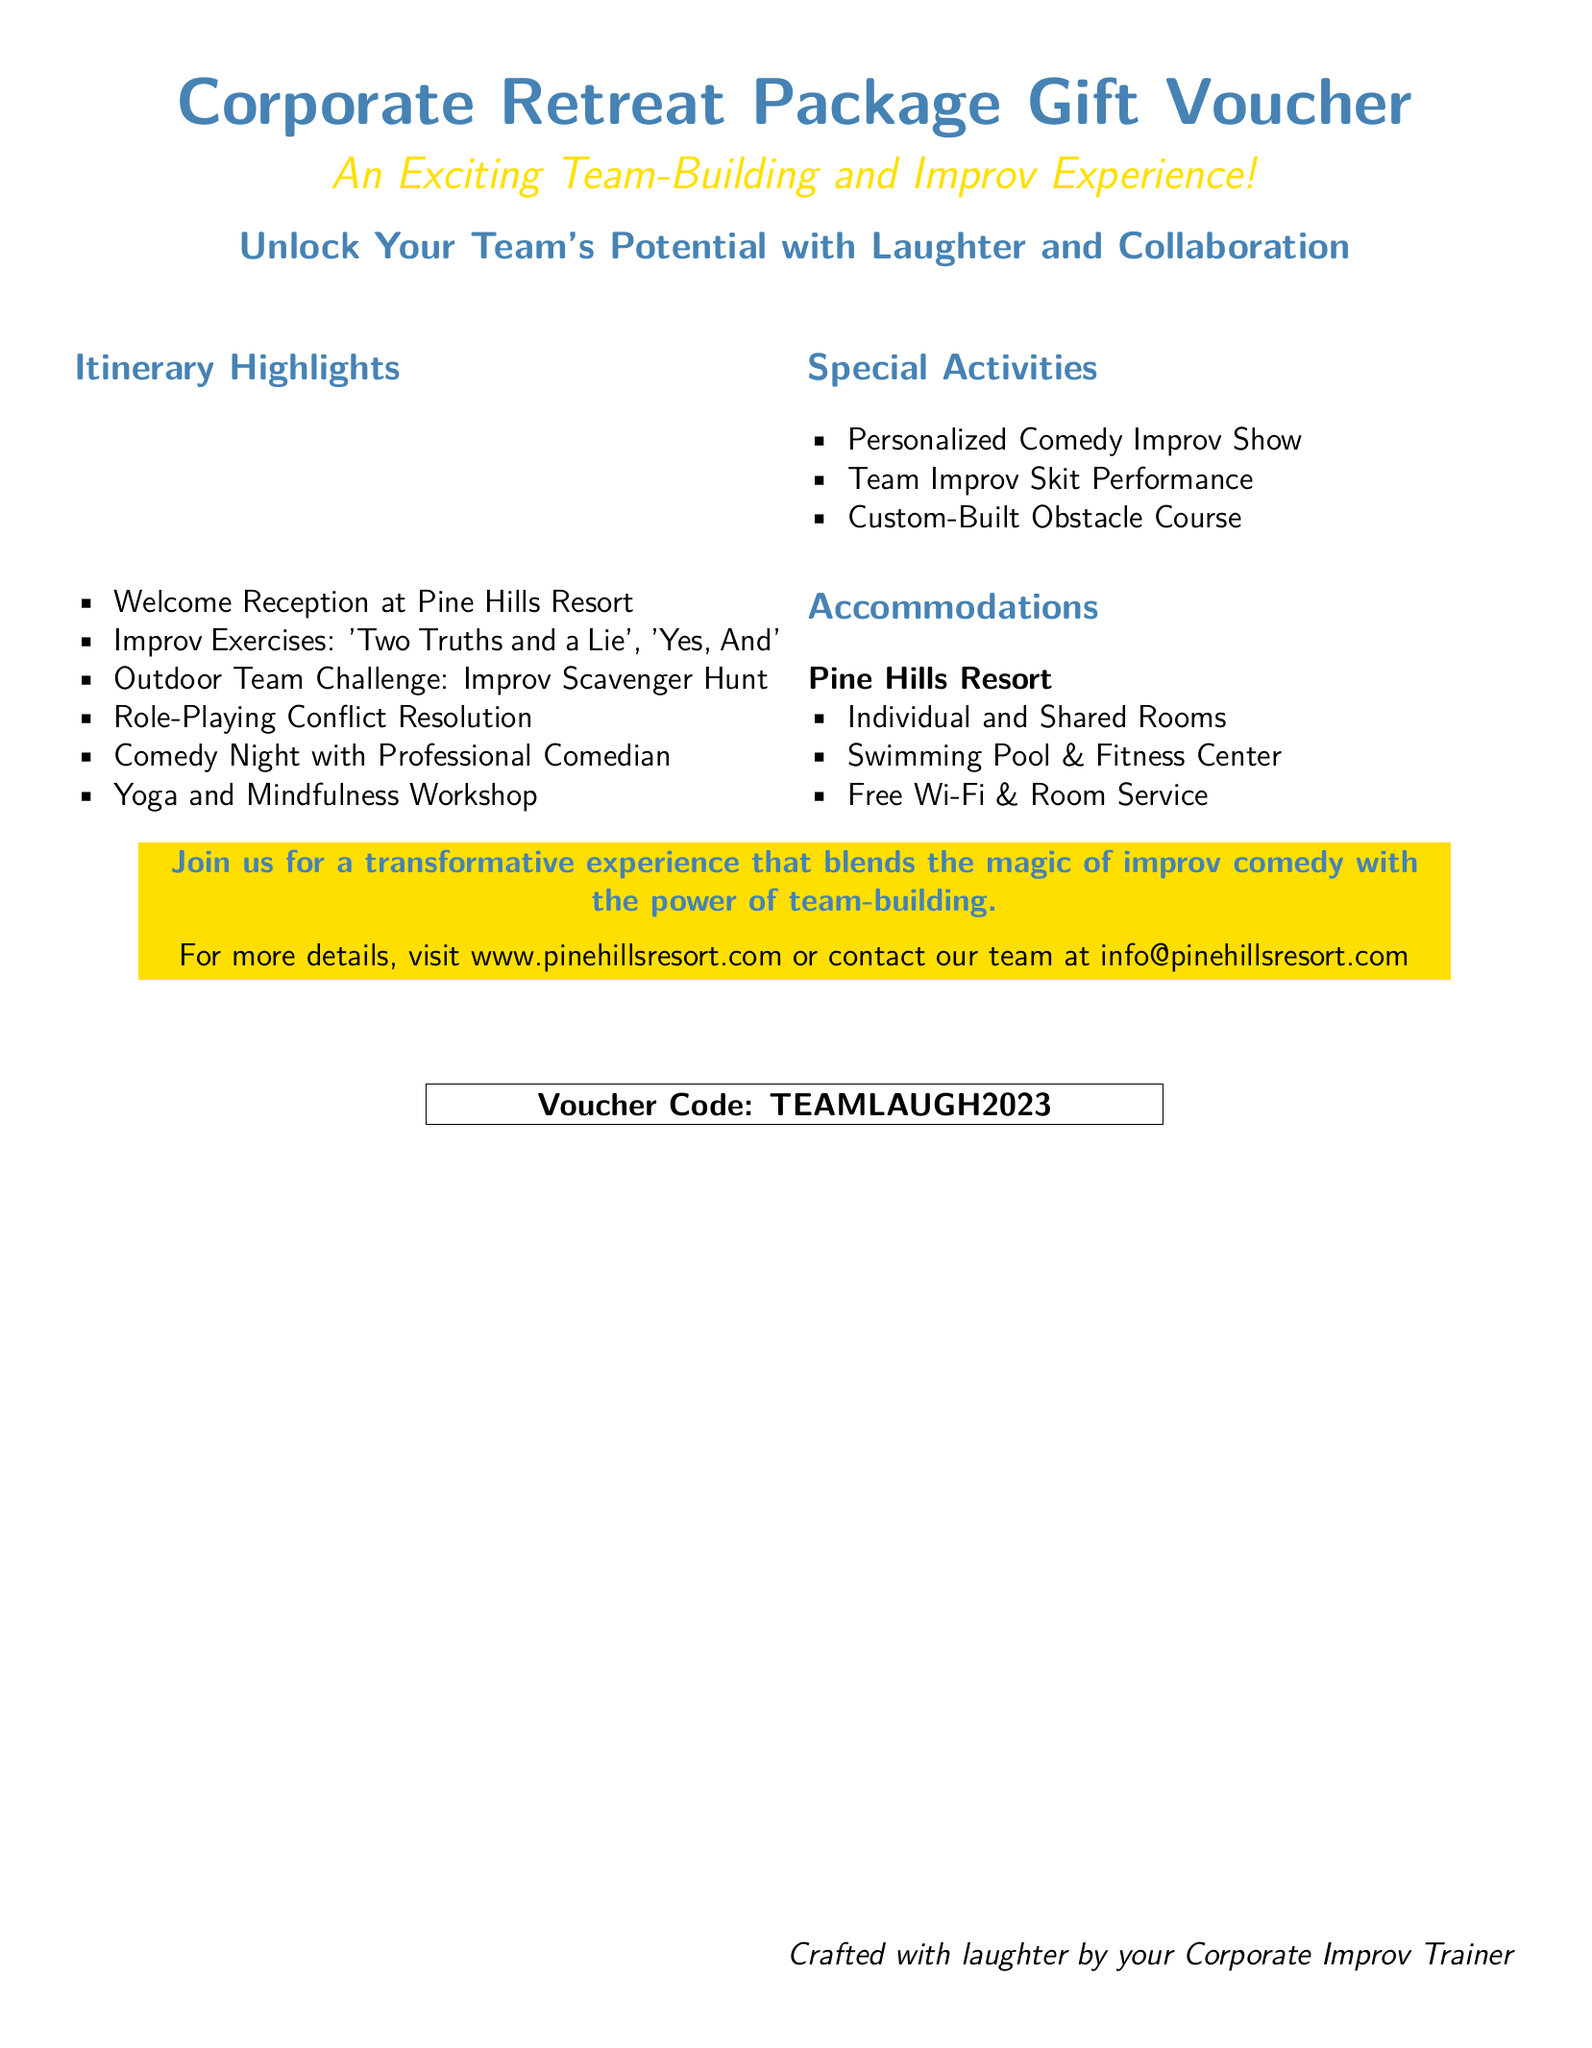What is the title of the document? The title of the document is prominently displayed at the top.
Answer: Corporate Retreat Package Gift Voucher What is the name of the resort? The name of the resort is mentioned in the Accommodations section.
Answer: Pine Hills Resort How many activities are listed under Special Activities? The number of activities in this section is counted for clarity.
Answer: Three What is one of the improv exercises mentioned in the itinerary? The improvisational exercises are listed in the Itinerary Highlights.
Answer: Yes, And What is the voucher code? The voucher code is clearly indicated in a highlighted box at the bottom.
Answer: TEAMLAUGH2023 Which type of accommodation is available at the resort? The Accommodations section provides information on the types of rooms.
Answer: Individual and Shared Rooms What unique feature is included in the itinerary that focuses on mindfulness? This feature relates to well-being activities mentioned in the itinerary highlights.
Answer: Yoga and Mindfulness Workshop What does the document invite teams to join? The concluding invitation encapsulates the experience offered.
Answer: A transformative experience What can participants perform as part of the Special Activities? The Special Activities section includes details on performances.
Answer: Team Improv Skit Performance 